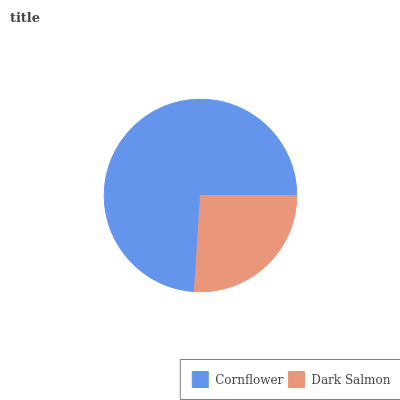Is Dark Salmon the minimum?
Answer yes or no. Yes. Is Cornflower the maximum?
Answer yes or no. Yes. Is Dark Salmon the maximum?
Answer yes or no. No. Is Cornflower greater than Dark Salmon?
Answer yes or no. Yes. Is Dark Salmon less than Cornflower?
Answer yes or no. Yes. Is Dark Salmon greater than Cornflower?
Answer yes or no. No. Is Cornflower less than Dark Salmon?
Answer yes or no. No. Is Cornflower the high median?
Answer yes or no. Yes. Is Dark Salmon the low median?
Answer yes or no. Yes. Is Dark Salmon the high median?
Answer yes or no. No. Is Cornflower the low median?
Answer yes or no. No. 